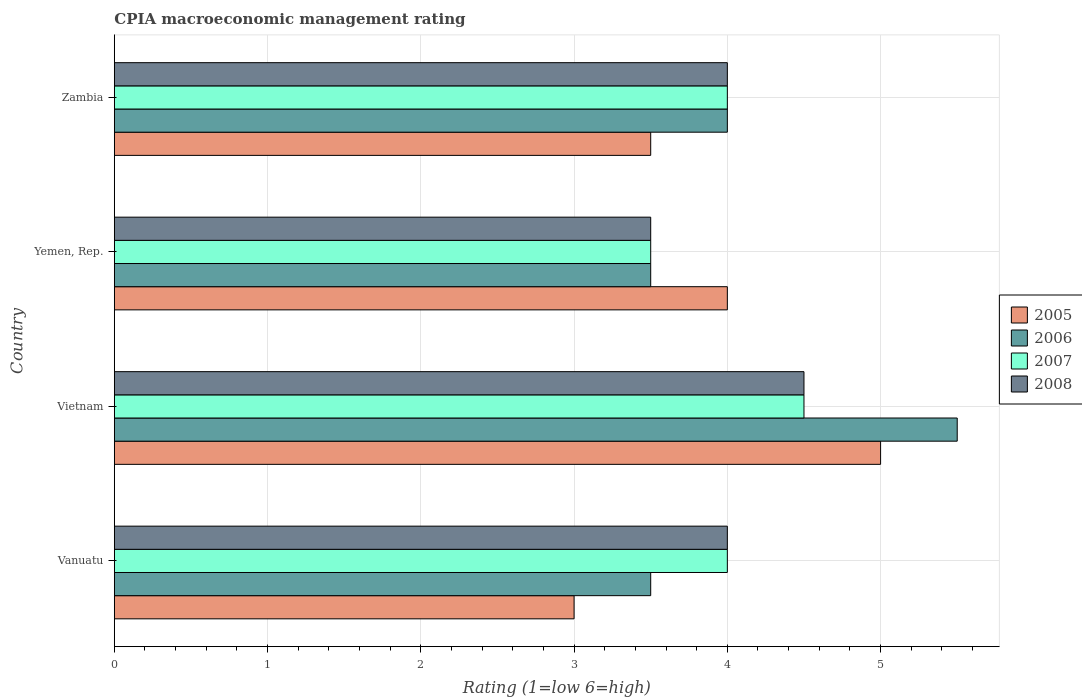How many groups of bars are there?
Your answer should be very brief. 4. Are the number of bars per tick equal to the number of legend labels?
Your answer should be compact. Yes. Are the number of bars on each tick of the Y-axis equal?
Your answer should be very brief. Yes. How many bars are there on the 4th tick from the bottom?
Provide a short and direct response. 4. What is the label of the 3rd group of bars from the top?
Provide a short and direct response. Vietnam. Across all countries, what is the maximum CPIA rating in 2006?
Give a very brief answer. 5.5. In which country was the CPIA rating in 2006 maximum?
Your answer should be very brief. Vietnam. In which country was the CPIA rating in 2006 minimum?
Keep it short and to the point. Vanuatu. What is the difference between the CPIA rating in 2006 in Vietnam and the CPIA rating in 2005 in Zambia?
Provide a short and direct response. 2. What is the average CPIA rating in 2006 per country?
Your answer should be compact. 4.12. What is the ratio of the CPIA rating in 2005 in Vietnam to that in Zambia?
Your response must be concise. 1.43. Is the difference between the CPIA rating in 2005 in Vanuatu and Vietnam greater than the difference between the CPIA rating in 2006 in Vanuatu and Vietnam?
Provide a short and direct response. No. In how many countries, is the CPIA rating in 2007 greater than the average CPIA rating in 2007 taken over all countries?
Your answer should be very brief. 1. Is it the case that in every country, the sum of the CPIA rating in 2006 and CPIA rating in 2005 is greater than the CPIA rating in 2008?
Your answer should be very brief. Yes. Are all the bars in the graph horizontal?
Make the answer very short. Yes. What is the difference between two consecutive major ticks on the X-axis?
Provide a succinct answer. 1. Does the graph contain any zero values?
Keep it short and to the point. No. Does the graph contain grids?
Give a very brief answer. Yes. What is the title of the graph?
Your answer should be compact. CPIA macroeconomic management rating. Does "1979" appear as one of the legend labels in the graph?
Your answer should be compact. No. What is the label or title of the X-axis?
Offer a very short reply. Rating (1=low 6=high). What is the Rating (1=low 6=high) of 2007 in Vanuatu?
Keep it short and to the point. 4. What is the Rating (1=low 6=high) of 2008 in Vanuatu?
Give a very brief answer. 4. What is the Rating (1=low 6=high) of 2005 in Vietnam?
Keep it short and to the point. 5. What is the Rating (1=low 6=high) of 2006 in Vietnam?
Make the answer very short. 5.5. What is the Rating (1=low 6=high) in 2007 in Vietnam?
Provide a short and direct response. 4.5. What is the Rating (1=low 6=high) of 2006 in Yemen, Rep.?
Your answer should be very brief. 3.5. What is the Rating (1=low 6=high) in 2007 in Yemen, Rep.?
Keep it short and to the point. 3.5. What is the Rating (1=low 6=high) of 2008 in Yemen, Rep.?
Keep it short and to the point. 3.5. What is the Rating (1=low 6=high) of 2005 in Zambia?
Provide a succinct answer. 3.5. What is the Rating (1=low 6=high) of 2006 in Zambia?
Offer a terse response. 4. Across all countries, what is the maximum Rating (1=low 6=high) in 2005?
Ensure brevity in your answer.  5. Across all countries, what is the maximum Rating (1=low 6=high) of 2006?
Ensure brevity in your answer.  5.5. Across all countries, what is the maximum Rating (1=low 6=high) in 2008?
Offer a very short reply. 4.5. Across all countries, what is the minimum Rating (1=low 6=high) of 2006?
Provide a succinct answer. 3.5. What is the total Rating (1=low 6=high) in 2005 in the graph?
Give a very brief answer. 15.5. What is the total Rating (1=low 6=high) of 2008 in the graph?
Your response must be concise. 16. What is the difference between the Rating (1=low 6=high) in 2007 in Vanuatu and that in Vietnam?
Give a very brief answer. -0.5. What is the difference between the Rating (1=low 6=high) of 2005 in Vanuatu and that in Yemen, Rep.?
Keep it short and to the point. -1. What is the difference between the Rating (1=low 6=high) in 2007 in Vanuatu and that in Yemen, Rep.?
Keep it short and to the point. 0.5. What is the difference between the Rating (1=low 6=high) of 2005 in Vanuatu and that in Zambia?
Make the answer very short. -0.5. What is the difference between the Rating (1=low 6=high) in 2006 in Vanuatu and that in Zambia?
Your answer should be compact. -0.5. What is the difference between the Rating (1=low 6=high) in 2008 in Vanuatu and that in Zambia?
Your answer should be compact. 0. What is the difference between the Rating (1=low 6=high) in 2007 in Vietnam and that in Yemen, Rep.?
Ensure brevity in your answer.  1. What is the difference between the Rating (1=low 6=high) in 2005 in Vietnam and that in Zambia?
Your answer should be very brief. 1.5. What is the difference between the Rating (1=low 6=high) in 2006 in Vietnam and that in Zambia?
Offer a very short reply. 1.5. What is the difference between the Rating (1=low 6=high) of 2007 in Vietnam and that in Zambia?
Ensure brevity in your answer.  0.5. What is the difference between the Rating (1=low 6=high) of 2006 in Yemen, Rep. and that in Zambia?
Keep it short and to the point. -0.5. What is the difference between the Rating (1=low 6=high) of 2008 in Yemen, Rep. and that in Zambia?
Your answer should be very brief. -0.5. What is the difference between the Rating (1=low 6=high) in 2005 in Vanuatu and the Rating (1=low 6=high) in 2006 in Vietnam?
Give a very brief answer. -2.5. What is the difference between the Rating (1=low 6=high) in 2005 in Vanuatu and the Rating (1=low 6=high) in 2008 in Vietnam?
Keep it short and to the point. -1.5. What is the difference between the Rating (1=low 6=high) in 2006 in Vanuatu and the Rating (1=low 6=high) in 2008 in Vietnam?
Your answer should be very brief. -1. What is the difference between the Rating (1=low 6=high) in 2007 in Vanuatu and the Rating (1=low 6=high) in 2008 in Vietnam?
Ensure brevity in your answer.  -0.5. What is the difference between the Rating (1=low 6=high) in 2005 in Vanuatu and the Rating (1=low 6=high) in 2006 in Yemen, Rep.?
Give a very brief answer. -0.5. What is the difference between the Rating (1=low 6=high) in 2005 in Vanuatu and the Rating (1=low 6=high) in 2007 in Yemen, Rep.?
Give a very brief answer. -0.5. What is the difference between the Rating (1=low 6=high) of 2005 in Vanuatu and the Rating (1=low 6=high) of 2008 in Yemen, Rep.?
Make the answer very short. -0.5. What is the difference between the Rating (1=low 6=high) in 2006 in Vanuatu and the Rating (1=low 6=high) in 2007 in Yemen, Rep.?
Provide a succinct answer. 0. What is the difference between the Rating (1=low 6=high) in 2005 in Vanuatu and the Rating (1=low 6=high) in 2008 in Zambia?
Keep it short and to the point. -1. What is the difference between the Rating (1=low 6=high) in 2006 in Vanuatu and the Rating (1=low 6=high) in 2008 in Zambia?
Offer a terse response. -0.5. What is the difference between the Rating (1=low 6=high) of 2007 in Vanuatu and the Rating (1=low 6=high) of 2008 in Zambia?
Your response must be concise. 0. What is the difference between the Rating (1=low 6=high) in 2005 in Vietnam and the Rating (1=low 6=high) in 2007 in Yemen, Rep.?
Keep it short and to the point. 1.5. What is the difference between the Rating (1=low 6=high) of 2006 in Vietnam and the Rating (1=low 6=high) of 2007 in Yemen, Rep.?
Your answer should be compact. 2. What is the difference between the Rating (1=low 6=high) in 2006 in Vietnam and the Rating (1=low 6=high) in 2008 in Yemen, Rep.?
Your answer should be very brief. 2. What is the difference between the Rating (1=low 6=high) in 2005 in Vietnam and the Rating (1=low 6=high) in 2006 in Zambia?
Your response must be concise. 1. What is the difference between the Rating (1=low 6=high) in 2005 in Vietnam and the Rating (1=low 6=high) in 2008 in Zambia?
Provide a short and direct response. 1. What is the difference between the Rating (1=low 6=high) in 2005 in Yemen, Rep. and the Rating (1=low 6=high) in 2006 in Zambia?
Provide a short and direct response. 0. What is the difference between the Rating (1=low 6=high) of 2005 in Yemen, Rep. and the Rating (1=low 6=high) of 2007 in Zambia?
Ensure brevity in your answer.  0. What is the difference between the Rating (1=low 6=high) in 2005 in Yemen, Rep. and the Rating (1=low 6=high) in 2008 in Zambia?
Your answer should be compact. 0. What is the difference between the Rating (1=low 6=high) of 2006 in Yemen, Rep. and the Rating (1=low 6=high) of 2008 in Zambia?
Provide a short and direct response. -0.5. What is the difference between the Rating (1=low 6=high) in 2007 in Yemen, Rep. and the Rating (1=low 6=high) in 2008 in Zambia?
Ensure brevity in your answer.  -0.5. What is the average Rating (1=low 6=high) in 2005 per country?
Give a very brief answer. 3.88. What is the average Rating (1=low 6=high) of 2006 per country?
Give a very brief answer. 4.12. What is the average Rating (1=low 6=high) in 2008 per country?
Ensure brevity in your answer.  4. What is the difference between the Rating (1=low 6=high) in 2005 and Rating (1=low 6=high) in 2007 in Vanuatu?
Offer a terse response. -1. What is the difference between the Rating (1=low 6=high) of 2006 and Rating (1=low 6=high) of 2007 in Vanuatu?
Offer a terse response. -0.5. What is the difference between the Rating (1=low 6=high) in 2006 and Rating (1=low 6=high) in 2008 in Vanuatu?
Offer a terse response. -0.5. What is the difference between the Rating (1=low 6=high) in 2005 and Rating (1=low 6=high) in 2007 in Vietnam?
Your answer should be very brief. 0.5. What is the difference between the Rating (1=low 6=high) in 2006 and Rating (1=low 6=high) in 2008 in Vietnam?
Your answer should be very brief. 1. What is the difference between the Rating (1=low 6=high) in 2005 and Rating (1=low 6=high) in 2006 in Yemen, Rep.?
Your answer should be very brief. 0.5. What is the difference between the Rating (1=low 6=high) of 2005 and Rating (1=low 6=high) of 2007 in Yemen, Rep.?
Keep it short and to the point. 0.5. What is the difference between the Rating (1=low 6=high) of 2005 and Rating (1=low 6=high) of 2008 in Yemen, Rep.?
Offer a terse response. 0.5. What is the difference between the Rating (1=low 6=high) in 2006 and Rating (1=low 6=high) in 2007 in Yemen, Rep.?
Your response must be concise. 0. What is the difference between the Rating (1=low 6=high) in 2005 and Rating (1=low 6=high) in 2008 in Zambia?
Your answer should be compact. -0.5. What is the difference between the Rating (1=low 6=high) of 2006 and Rating (1=low 6=high) of 2008 in Zambia?
Your answer should be compact. 0. What is the ratio of the Rating (1=low 6=high) in 2006 in Vanuatu to that in Vietnam?
Your answer should be compact. 0.64. What is the ratio of the Rating (1=low 6=high) of 2005 in Vanuatu to that in Yemen, Rep.?
Your response must be concise. 0.75. What is the ratio of the Rating (1=low 6=high) in 2007 in Vanuatu to that in Yemen, Rep.?
Ensure brevity in your answer.  1.14. What is the ratio of the Rating (1=low 6=high) of 2005 in Vanuatu to that in Zambia?
Provide a succinct answer. 0.86. What is the ratio of the Rating (1=low 6=high) in 2008 in Vanuatu to that in Zambia?
Offer a terse response. 1. What is the ratio of the Rating (1=low 6=high) of 2005 in Vietnam to that in Yemen, Rep.?
Offer a very short reply. 1.25. What is the ratio of the Rating (1=low 6=high) of 2006 in Vietnam to that in Yemen, Rep.?
Offer a very short reply. 1.57. What is the ratio of the Rating (1=low 6=high) of 2008 in Vietnam to that in Yemen, Rep.?
Offer a very short reply. 1.29. What is the ratio of the Rating (1=low 6=high) of 2005 in Vietnam to that in Zambia?
Give a very brief answer. 1.43. What is the ratio of the Rating (1=low 6=high) in 2006 in Vietnam to that in Zambia?
Keep it short and to the point. 1.38. What is the ratio of the Rating (1=low 6=high) in 2005 in Yemen, Rep. to that in Zambia?
Offer a terse response. 1.14. What is the ratio of the Rating (1=low 6=high) in 2006 in Yemen, Rep. to that in Zambia?
Make the answer very short. 0.88. What is the difference between the highest and the lowest Rating (1=low 6=high) of 2005?
Your response must be concise. 2. What is the difference between the highest and the lowest Rating (1=low 6=high) in 2007?
Keep it short and to the point. 1. What is the difference between the highest and the lowest Rating (1=low 6=high) of 2008?
Your answer should be compact. 1. 